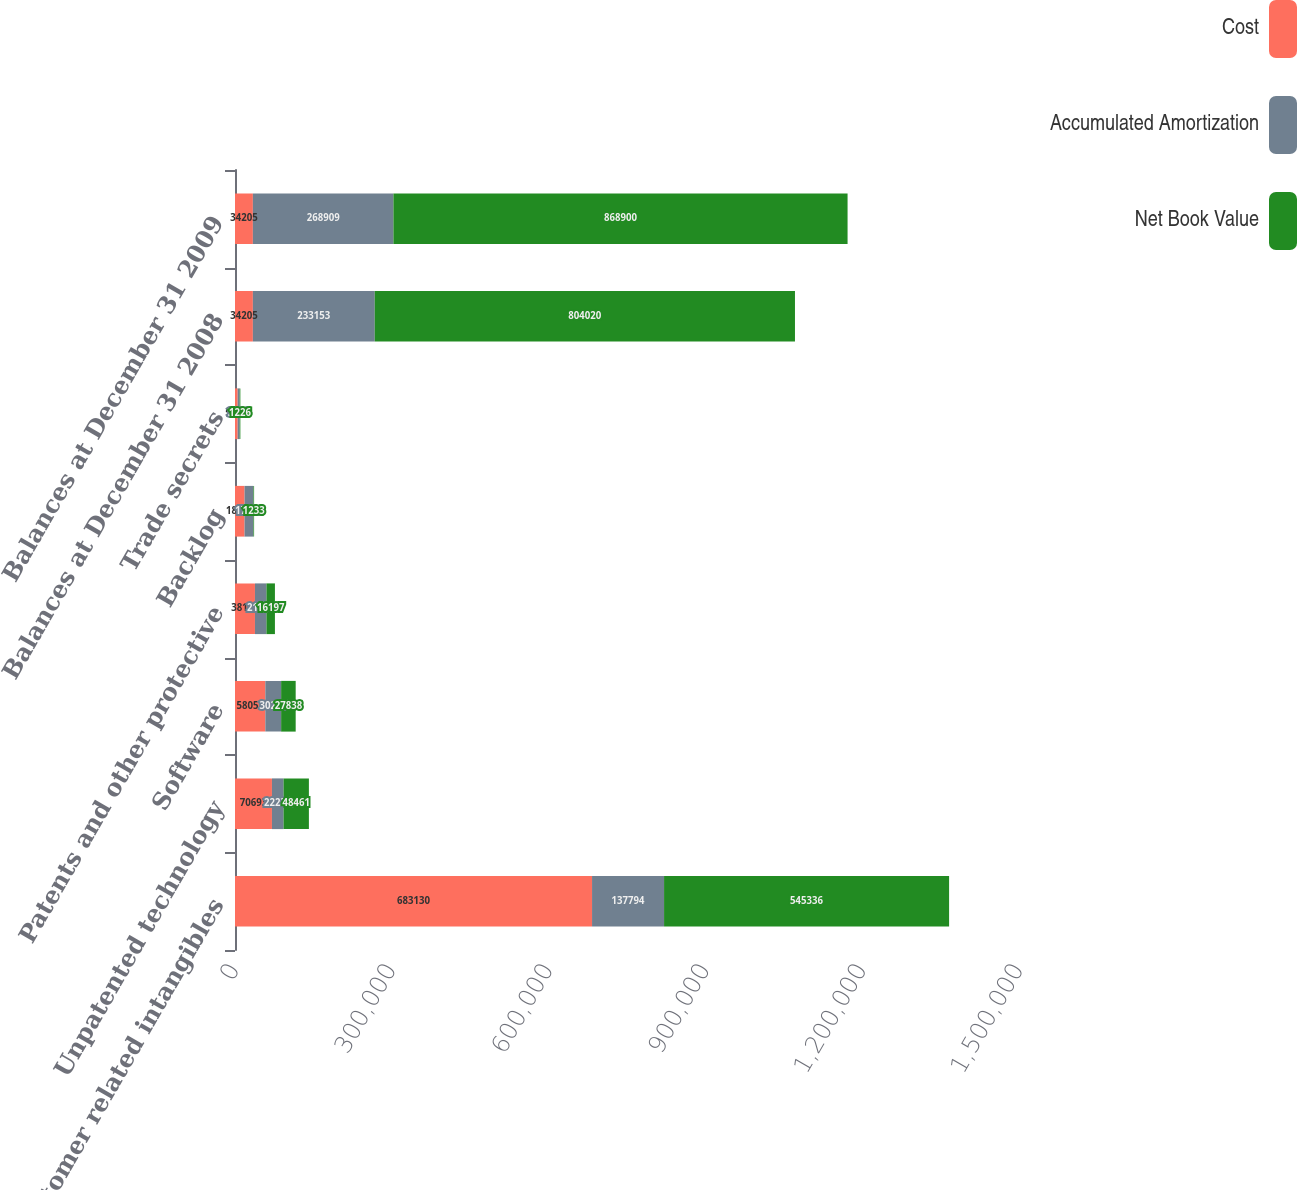Convert chart to OTSL. <chart><loc_0><loc_0><loc_500><loc_500><stacked_bar_chart><ecel><fcel>Customer related intangibles<fcel>Unpatented technology<fcel>Software<fcel>Patents and other protective<fcel>Backlog<fcel>Trade secrets<fcel>Balances at December 31 2008<fcel>Balances at December 31 2009<nl><fcel>Cost<fcel>683130<fcel>70693<fcel>58053<fcel>38195<fcel>18257<fcel>5116<fcel>34205<fcel>34205<nl><fcel>Accumulated Amortization<fcel>137794<fcel>22232<fcel>30215<fcel>21998<fcel>17024<fcel>3890<fcel>233153<fcel>268909<nl><fcel>Net Book Value<fcel>545336<fcel>48461<fcel>27838<fcel>16197<fcel>1233<fcel>1226<fcel>804020<fcel>868900<nl></chart> 